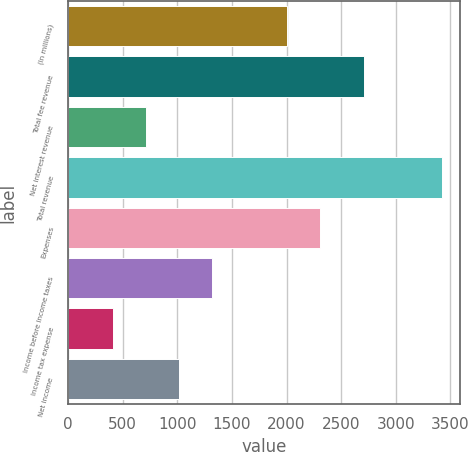Convert chart. <chart><loc_0><loc_0><loc_500><loc_500><bar_chart><fcel>(In millions)<fcel>Total fee revenue<fcel>Net interest revenue<fcel>Total revenue<fcel>Expenses<fcel>Income before income taxes<fcel>Income tax expense<fcel>Net income<nl><fcel>2007<fcel>2707<fcel>715.5<fcel>3420<fcel>2307.5<fcel>1316.5<fcel>415<fcel>1016<nl></chart> 